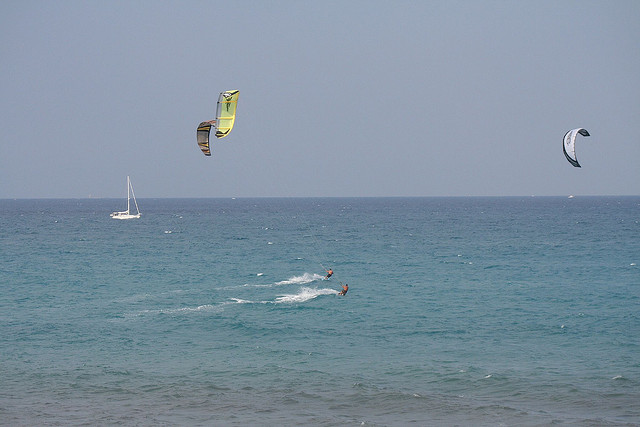Where is the sailboat located relative to the parasails? The sailboat is located to the left side of the parasails in the image, slightly further out towards the horizon. 